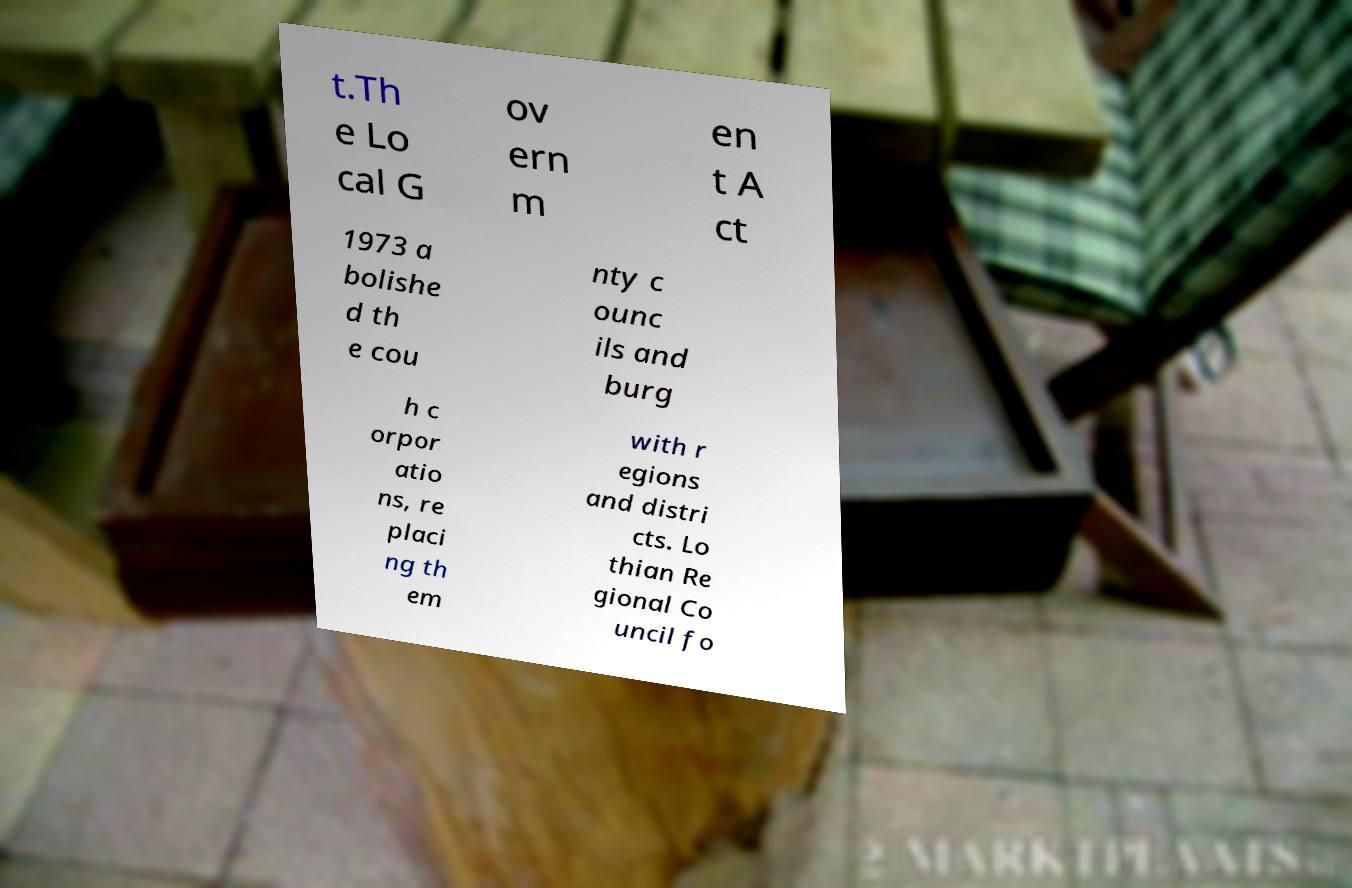Could you extract and type out the text from this image? t.Th e Lo cal G ov ern m en t A ct 1973 a bolishe d th e cou nty c ounc ils and burg h c orpor atio ns, re placi ng th em with r egions and distri cts. Lo thian Re gional Co uncil fo 